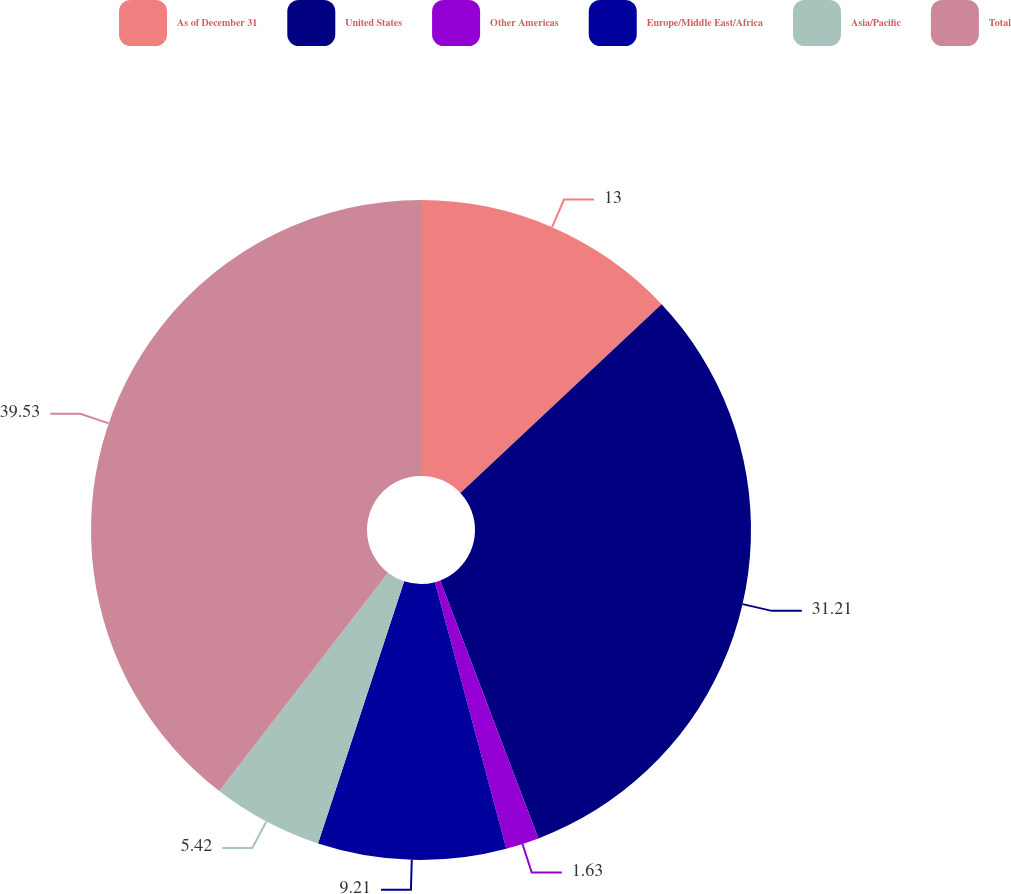Convert chart. <chart><loc_0><loc_0><loc_500><loc_500><pie_chart><fcel>As of December 31<fcel>United States<fcel>Other Americas<fcel>Europe/Middle East/Africa<fcel>Asia/Pacific<fcel>Total<nl><fcel>13.0%<fcel>31.2%<fcel>1.63%<fcel>9.21%<fcel>5.42%<fcel>39.52%<nl></chart> 